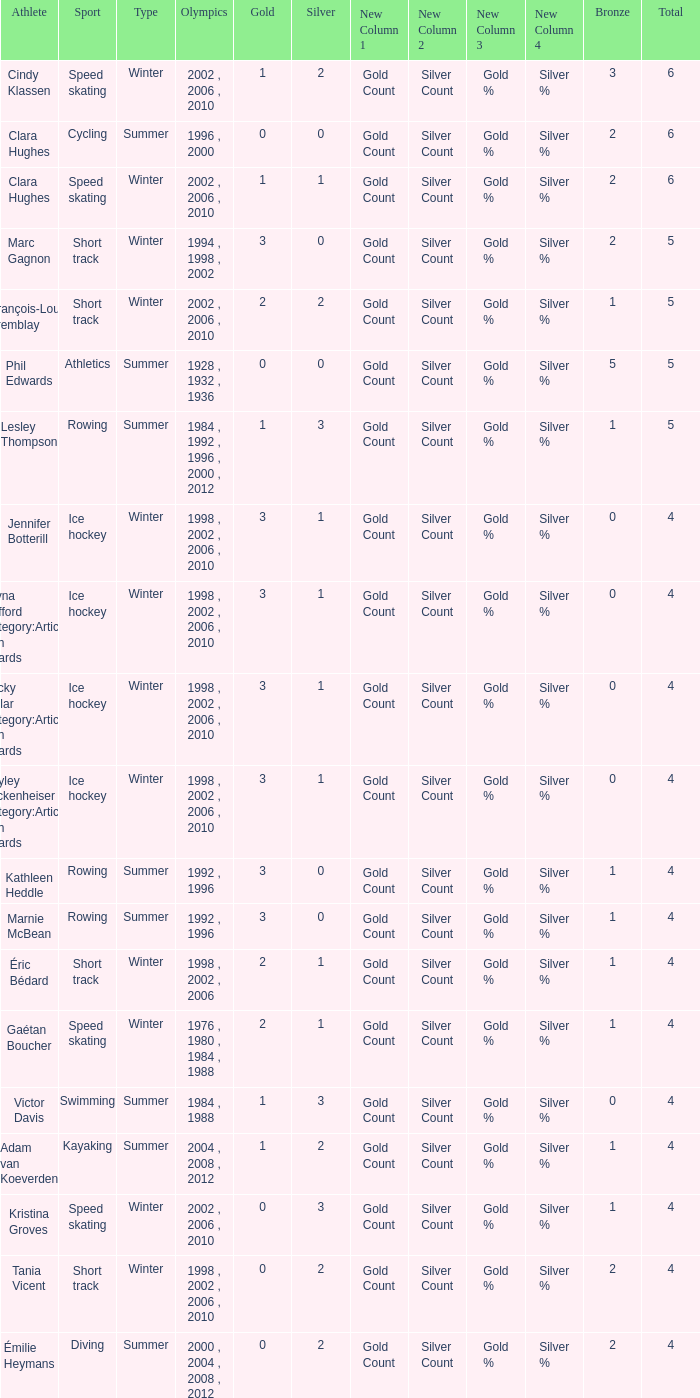What is the lowest number of bronze a short track athlete with 0 gold medals has? 2.0. 